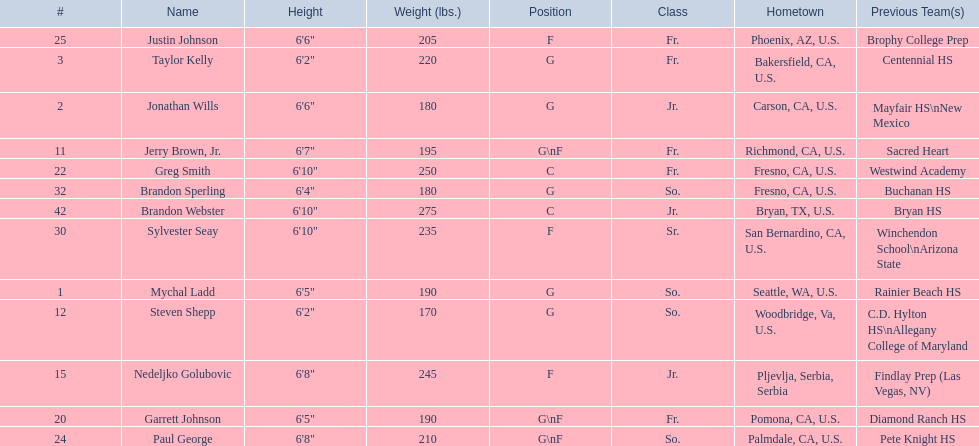Where were all of the players born? So., Jr., Fr., Fr., So., Jr., Fr., Fr., So., Fr., Sr., So., Jr. Write the full table. {'header': ['#', 'Name', 'Height', 'Weight (lbs.)', 'Position', 'Class', 'Hometown', 'Previous Team(s)'], 'rows': [['25', 'Justin Johnson', '6\'6"', '205', 'F', 'Fr.', 'Phoenix, AZ, U.S.', 'Brophy College Prep'], ['3', 'Taylor Kelly', '6\'2"', '220', 'G', 'Fr.', 'Bakersfield, CA, U.S.', 'Centennial HS'], ['2', 'Jonathan Wills', '6\'6"', '180', 'G', 'Jr.', 'Carson, CA, U.S.', 'Mayfair HS\\nNew Mexico'], ['11', 'Jerry Brown, Jr.', '6\'7"', '195', 'G\\nF', 'Fr.', 'Richmond, CA, U.S.', 'Sacred Heart'], ['22', 'Greg Smith', '6\'10"', '250', 'C', 'Fr.', 'Fresno, CA, U.S.', 'Westwind Academy'], ['32', 'Brandon Sperling', '6\'4"', '180', 'G', 'So.', 'Fresno, CA, U.S.', 'Buchanan HS'], ['42', 'Brandon Webster', '6\'10"', '275', 'C', 'Jr.', 'Bryan, TX, U.S.', 'Bryan HS'], ['30', 'Sylvester Seay', '6\'10"', '235', 'F', 'Sr.', 'San Bernardino, CA, U.S.', 'Winchendon School\\nArizona State'], ['1', 'Mychal Ladd', '6\'5"', '190', 'G', 'So.', 'Seattle, WA, U.S.', 'Rainier Beach HS'], ['12', 'Steven Shepp', '6\'2"', '170', 'G', 'So.', 'Woodbridge, Va, U.S.', 'C.D. Hylton HS\\nAllegany College of Maryland'], ['15', 'Nedeljko Golubovic', '6\'8"', '245', 'F', 'Jr.', 'Pljevlja, Serbia, Serbia', 'Findlay Prep (Las Vegas, NV)'], ['20', 'Garrett Johnson', '6\'5"', '190', 'G\\nF', 'Fr.', 'Pomona, CA, U.S.', 'Diamond Ranch HS'], ['24', 'Paul George', '6\'8"', '210', 'G\\nF', 'So.', 'Palmdale, CA, U.S.', 'Pete Knight HS']]} Who is the one from serbia? Nedeljko Golubovic. 